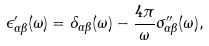<formula> <loc_0><loc_0><loc_500><loc_500>\epsilon ^ { \prime } _ { \alpha \beta } ( \omega ) = \delta _ { \alpha \beta } ( \omega ) - \frac { 4 \pi } { \omega } \sigma ^ { \prime \prime } _ { \alpha \beta } ( \omega ) ,</formula> 